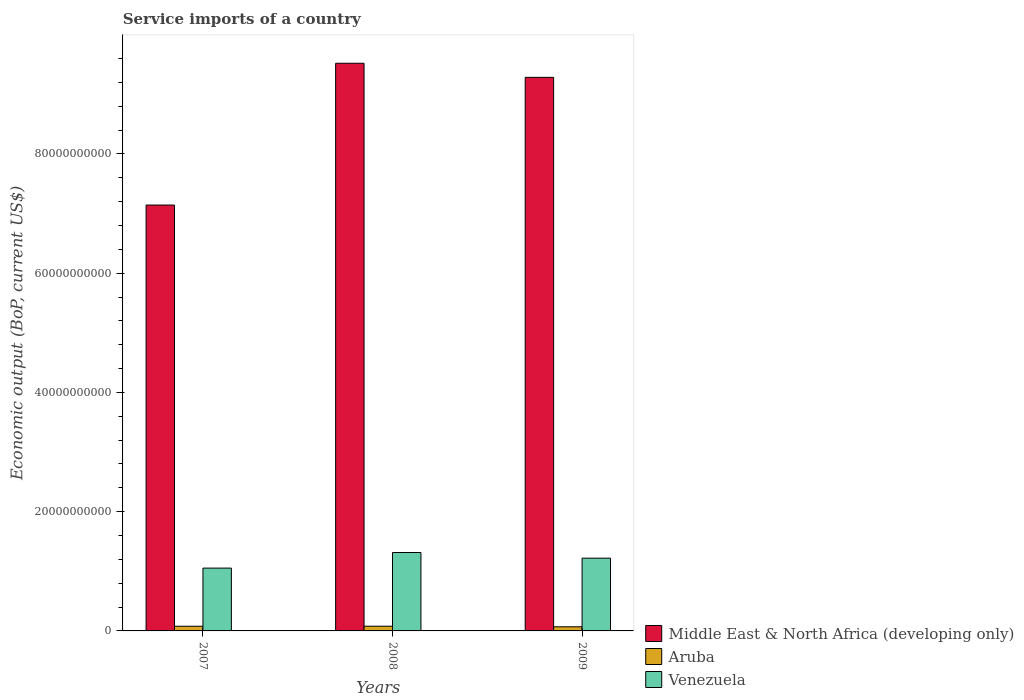How many groups of bars are there?
Offer a terse response. 3. How many bars are there on the 1st tick from the left?
Provide a succinct answer. 3. How many bars are there on the 1st tick from the right?
Your answer should be compact. 3. What is the label of the 1st group of bars from the left?
Keep it short and to the point. 2007. In how many cases, is the number of bars for a given year not equal to the number of legend labels?
Make the answer very short. 0. What is the service imports in Aruba in 2008?
Keep it short and to the point. 7.94e+08. Across all years, what is the maximum service imports in Venezuela?
Make the answer very short. 1.32e+1. Across all years, what is the minimum service imports in Aruba?
Your response must be concise. 6.93e+08. In which year was the service imports in Middle East & North Africa (developing only) maximum?
Provide a short and direct response. 2008. What is the total service imports in Venezuela in the graph?
Provide a succinct answer. 3.59e+1. What is the difference between the service imports in Venezuela in 2007 and that in 2009?
Provide a short and direct response. -1.67e+09. What is the difference between the service imports in Middle East & North Africa (developing only) in 2008 and the service imports in Venezuela in 2007?
Your response must be concise. 8.47e+1. What is the average service imports in Middle East & North Africa (developing only) per year?
Keep it short and to the point. 8.65e+1. In the year 2009, what is the difference between the service imports in Venezuela and service imports in Middle East & North Africa (developing only)?
Keep it short and to the point. -8.06e+1. In how many years, is the service imports in Middle East & North Africa (developing only) greater than 68000000000 US$?
Offer a terse response. 3. What is the ratio of the service imports in Middle East & North Africa (developing only) in 2007 to that in 2008?
Keep it short and to the point. 0.75. Is the service imports in Aruba in 2008 less than that in 2009?
Offer a very short reply. No. Is the difference between the service imports in Venezuela in 2007 and 2008 greater than the difference between the service imports in Middle East & North Africa (developing only) in 2007 and 2008?
Your answer should be compact. Yes. What is the difference between the highest and the second highest service imports in Venezuela?
Your response must be concise. 9.49e+08. What is the difference between the highest and the lowest service imports in Venezuela?
Your answer should be compact. 2.62e+09. In how many years, is the service imports in Venezuela greater than the average service imports in Venezuela taken over all years?
Offer a terse response. 2. What does the 2nd bar from the left in 2009 represents?
Give a very brief answer. Aruba. What does the 1st bar from the right in 2009 represents?
Provide a succinct answer. Venezuela. How many years are there in the graph?
Give a very brief answer. 3. Does the graph contain any zero values?
Your answer should be very brief. No. How many legend labels are there?
Offer a very short reply. 3. How are the legend labels stacked?
Offer a terse response. Vertical. What is the title of the graph?
Offer a terse response. Service imports of a country. What is the label or title of the Y-axis?
Provide a short and direct response. Economic output (BoP, current US$). What is the Economic output (BoP, current US$) in Middle East & North Africa (developing only) in 2007?
Your response must be concise. 7.14e+1. What is the Economic output (BoP, current US$) of Aruba in 2007?
Give a very brief answer. 7.85e+08. What is the Economic output (BoP, current US$) in Venezuela in 2007?
Your response must be concise. 1.05e+1. What is the Economic output (BoP, current US$) in Middle East & North Africa (developing only) in 2008?
Make the answer very short. 9.52e+1. What is the Economic output (BoP, current US$) in Aruba in 2008?
Your answer should be compact. 7.94e+08. What is the Economic output (BoP, current US$) of Venezuela in 2008?
Your answer should be compact. 1.32e+1. What is the Economic output (BoP, current US$) of Middle East & North Africa (developing only) in 2009?
Provide a succinct answer. 9.28e+1. What is the Economic output (BoP, current US$) in Aruba in 2009?
Make the answer very short. 6.93e+08. What is the Economic output (BoP, current US$) in Venezuela in 2009?
Make the answer very short. 1.22e+1. Across all years, what is the maximum Economic output (BoP, current US$) in Middle East & North Africa (developing only)?
Keep it short and to the point. 9.52e+1. Across all years, what is the maximum Economic output (BoP, current US$) in Aruba?
Keep it short and to the point. 7.94e+08. Across all years, what is the maximum Economic output (BoP, current US$) of Venezuela?
Keep it short and to the point. 1.32e+1. Across all years, what is the minimum Economic output (BoP, current US$) in Middle East & North Africa (developing only)?
Provide a short and direct response. 7.14e+1. Across all years, what is the minimum Economic output (BoP, current US$) of Aruba?
Ensure brevity in your answer.  6.93e+08. Across all years, what is the minimum Economic output (BoP, current US$) in Venezuela?
Ensure brevity in your answer.  1.05e+1. What is the total Economic output (BoP, current US$) of Middle East & North Africa (developing only) in the graph?
Ensure brevity in your answer.  2.59e+11. What is the total Economic output (BoP, current US$) of Aruba in the graph?
Provide a short and direct response. 2.27e+09. What is the total Economic output (BoP, current US$) in Venezuela in the graph?
Your response must be concise. 3.59e+1. What is the difference between the Economic output (BoP, current US$) of Middle East & North Africa (developing only) in 2007 and that in 2008?
Provide a succinct answer. -2.38e+1. What is the difference between the Economic output (BoP, current US$) in Aruba in 2007 and that in 2008?
Offer a very short reply. -8.49e+06. What is the difference between the Economic output (BoP, current US$) in Venezuela in 2007 and that in 2008?
Give a very brief answer. -2.62e+09. What is the difference between the Economic output (BoP, current US$) in Middle East & North Africa (developing only) in 2007 and that in 2009?
Your response must be concise. -2.14e+1. What is the difference between the Economic output (BoP, current US$) in Aruba in 2007 and that in 2009?
Give a very brief answer. 9.28e+07. What is the difference between the Economic output (BoP, current US$) in Venezuela in 2007 and that in 2009?
Your answer should be compact. -1.67e+09. What is the difference between the Economic output (BoP, current US$) of Middle East & North Africa (developing only) in 2008 and that in 2009?
Your answer should be compact. 2.36e+09. What is the difference between the Economic output (BoP, current US$) of Aruba in 2008 and that in 2009?
Offer a terse response. 1.01e+08. What is the difference between the Economic output (BoP, current US$) of Venezuela in 2008 and that in 2009?
Give a very brief answer. 9.49e+08. What is the difference between the Economic output (BoP, current US$) of Middle East & North Africa (developing only) in 2007 and the Economic output (BoP, current US$) of Aruba in 2008?
Ensure brevity in your answer.  7.06e+1. What is the difference between the Economic output (BoP, current US$) of Middle East & North Africa (developing only) in 2007 and the Economic output (BoP, current US$) of Venezuela in 2008?
Your response must be concise. 5.83e+1. What is the difference between the Economic output (BoP, current US$) of Aruba in 2007 and the Economic output (BoP, current US$) of Venezuela in 2008?
Ensure brevity in your answer.  -1.24e+1. What is the difference between the Economic output (BoP, current US$) in Middle East & North Africa (developing only) in 2007 and the Economic output (BoP, current US$) in Aruba in 2009?
Ensure brevity in your answer.  7.07e+1. What is the difference between the Economic output (BoP, current US$) of Middle East & North Africa (developing only) in 2007 and the Economic output (BoP, current US$) of Venezuela in 2009?
Your answer should be very brief. 5.92e+1. What is the difference between the Economic output (BoP, current US$) in Aruba in 2007 and the Economic output (BoP, current US$) in Venezuela in 2009?
Provide a succinct answer. -1.14e+1. What is the difference between the Economic output (BoP, current US$) in Middle East & North Africa (developing only) in 2008 and the Economic output (BoP, current US$) in Aruba in 2009?
Provide a succinct answer. 9.45e+1. What is the difference between the Economic output (BoP, current US$) in Middle East & North Africa (developing only) in 2008 and the Economic output (BoP, current US$) in Venezuela in 2009?
Your response must be concise. 8.30e+1. What is the difference between the Economic output (BoP, current US$) of Aruba in 2008 and the Economic output (BoP, current US$) of Venezuela in 2009?
Offer a terse response. -1.14e+1. What is the average Economic output (BoP, current US$) of Middle East & North Africa (developing only) per year?
Offer a very short reply. 8.65e+1. What is the average Economic output (BoP, current US$) of Aruba per year?
Give a very brief answer. 7.57e+08. What is the average Economic output (BoP, current US$) of Venezuela per year?
Your answer should be compact. 1.20e+1. In the year 2007, what is the difference between the Economic output (BoP, current US$) of Middle East & North Africa (developing only) and Economic output (BoP, current US$) of Aruba?
Give a very brief answer. 7.06e+1. In the year 2007, what is the difference between the Economic output (BoP, current US$) of Middle East & North Africa (developing only) and Economic output (BoP, current US$) of Venezuela?
Offer a very short reply. 6.09e+1. In the year 2007, what is the difference between the Economic output (BoP, current US$) in Aruba and Economic output (BoP, current US$) in Venezuela?
Offer a very short reply. -9.75e+09. In the year 2008, what is the difference between the Economic output (BoP, current US$) of Middle East & North Africa (developing only) and Economic output (BoP, current US$) of Aruba?
Provide a short and direct response. 9.44e+1. In the year 2008, what is the difference between the Economic output (BoP, current US$) of Middle East & North Africa (developing only) and Economic output (BoP, current US$) of Venezuela?
Your answer should be very brief. 8.21e+1. In the year 2008, what is the difference between the Economic output (BoP, current US$) of Aruba and Economic output (BoP, current US$) of Venezuela?
Provide a succinct answer. -1.24e+1. In the year 2009, what is the difference between the Economic output (BoP, current US$) in Middle East & North Africa (developing only) and Economic output (BoP, current US$) in Aruba?
Make the answer very short. 9.21e+1. In the year 2009, what is the difference between the Economic output (BoP, current US$) of Middle East & North Africa (developing only) and Economic output (BoP, current US$) of Venezuela?
Your response must be concise. 8.06e+1. In the year 2009, what is the difference between the Economic output (BoP, current US$) of Aruba and Economic output (BoP, current US$) of Venezuela?
Your response must be concise. -1.15e+1. What is the ratio of the Economic output (BoP, current US$) of Middle East & North Africa (developing only) in 2007 to that in 2008?
Your response must be concise. 0.75. What is the ratio of the Economic output (BoP, current US$) in Aruba in 2007 to that in 2008?
Your answer should be compact. 0.99. What is the ratio of the Economic output (BoP, current US$) of Venezuela in 2007 to that in 2008?
Make the answer very short. 0.8. What is the ratio of the Economic output (BoP, current US$) of Middle East & North Africa (developing only) in 2007 to that in 2009?
Make the answer very short. 0.77. What is the ratio of the Economic output (BoP, current US$) in Aruba in 2007 to that in 2009?
Make the answer very short. 1.13. What is the ratio of the Economic output (BoP, current US$) in Venezuela in 2007 to that in 2009?
Your answer should be compact. 0.86. What is the ratio of the Economic output (BoP, current US$) in Middle East & North Africa (developing only) in 2008 to that in 2009?
Offer a very short reply. 1.03. What is the ratio of the Economic output (BoP, current US$) of Aruba in 2008 to that in 2009?
Give a very brief answer. 1.15. What is the ratio of the Economic output (BoP, current US$) in Venezuela in 2008 to that in 2009?
Provide a short and direct response. 1.08. What is the difference between the highest and the second highest Economic output (BoP, current US$) in Middle East & North Africa (developing only)?
Keep it short and to the point. 2.36e+09. What is the difference between the highest and the second highest Economic output (BoP, current US$) of Aruba?
Give a very brief answer. 8.49e+06. What is the difference between the highest and the second highest Economic output (BoP, current US$) in Venezuela?
Offer a terse response. 9.49e+08. What is the difference between the highest and the lowest Economic output (BoP, current US$) in Middle East & North Africa (developing only)?
Your answer should be compact. 2.38e+1. What is the difference between the highest and the lowest Economic output (BoP, current US$) in Aruba?
Ensure brevity in your answer.  1.01e+08. What is the difference between the highest and the lowest Economic output (BoP, current US$) of Venezuela?
Make the answer very short. 2.62e+09. 